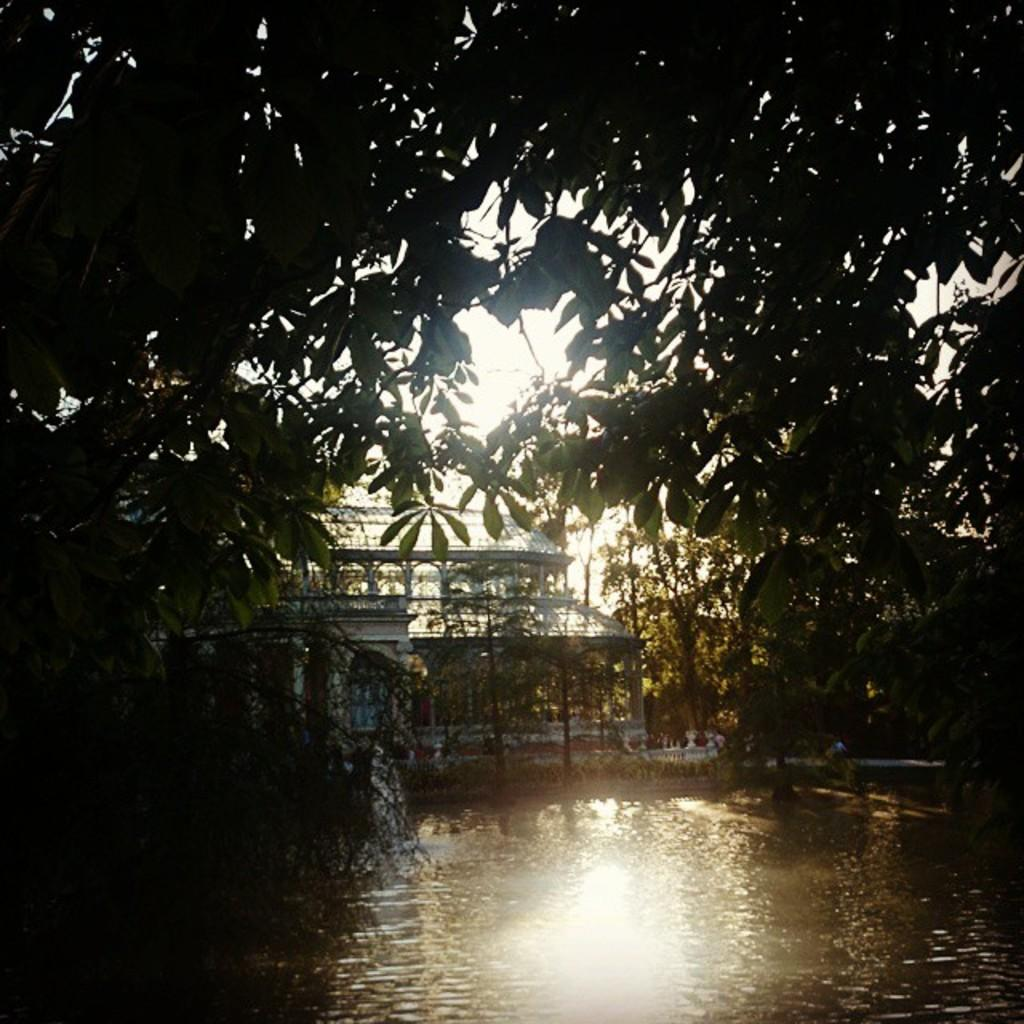What is the primary element visible in the image? There is water in the image. What type of structure can be seen in the image? There is a building in the image. What type of vegetation is present in the image? There are trees in the image. What type of receipt can be seen floating in the water in the image? There is no receipt present in the image; it only features water, a building, and trees. 